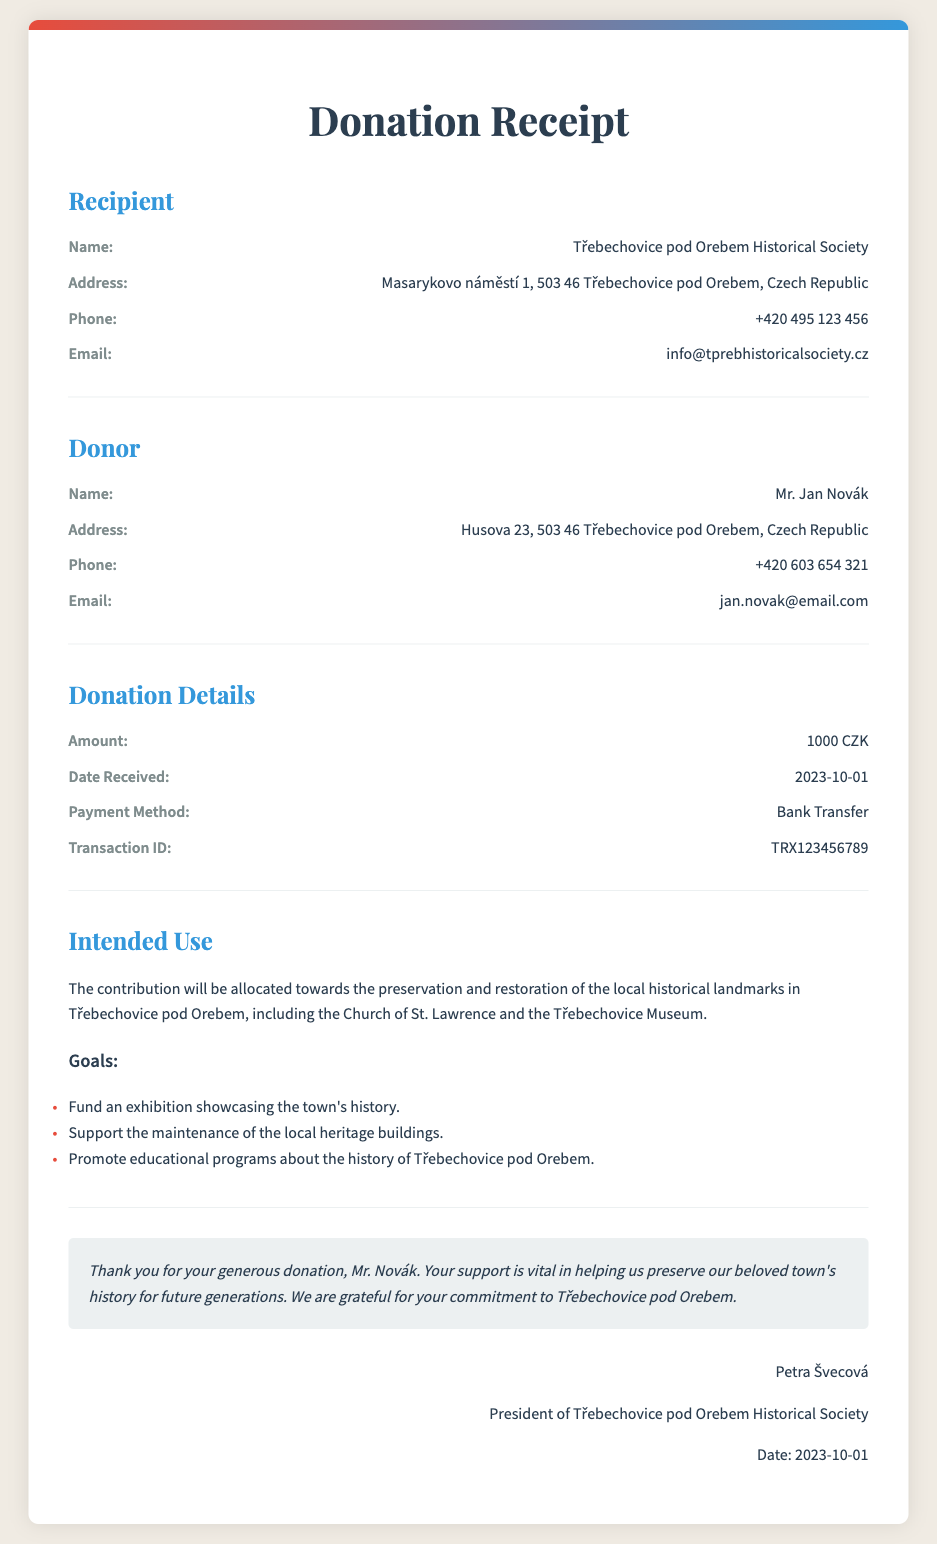what is the name of the recipient? The recipient of the donation is specified in the document as Třebechovice pod Orebem Historical Society.
Answer: Třebechovice pod Orebem Historical Society what is the address of the historical society? The address of the historical society is provided in the document as Masarykovo náměstí 1, 503 46 Třebechovice pod Orebem, Czech Republic.
Answer: Masarykovo náměstí 1, 503 46 Třebechovice pod Orebem, Czech Republic what was the amount of the donation? The amount of the donation is specified in the donation details section of the document as 1000 CZK.
Answer: 1000 CZK who made the donation? The donor's name is mentioned in the document as Mr. Jan Novák.
Answer: Mr. Jan Novák when was the donation received? The document states that the donation was received on the date of 2023-10-01.
Answer: 2023-10-01 what is the intended use of the contribution? The intended use of the contribution relates to the preservation and restoration of local historical landmarks, which is stated in the document.
Answer: Preservation and restoration of local historical landmarks what is one goal of the donation? The document lists goals of the donation, one of which is to fund an exhibition showcasing the town's history.
Answer: Fund an exhibition showcasing the town's history who signed the receipt? The signature section of the document identifies the signer as Petra Švecová.
Answer: Petra Švecová what payment method was used for the donation? The payment method for the donation is mentioned in the details as Bank Transfer.
Answer: Bank Transfer 